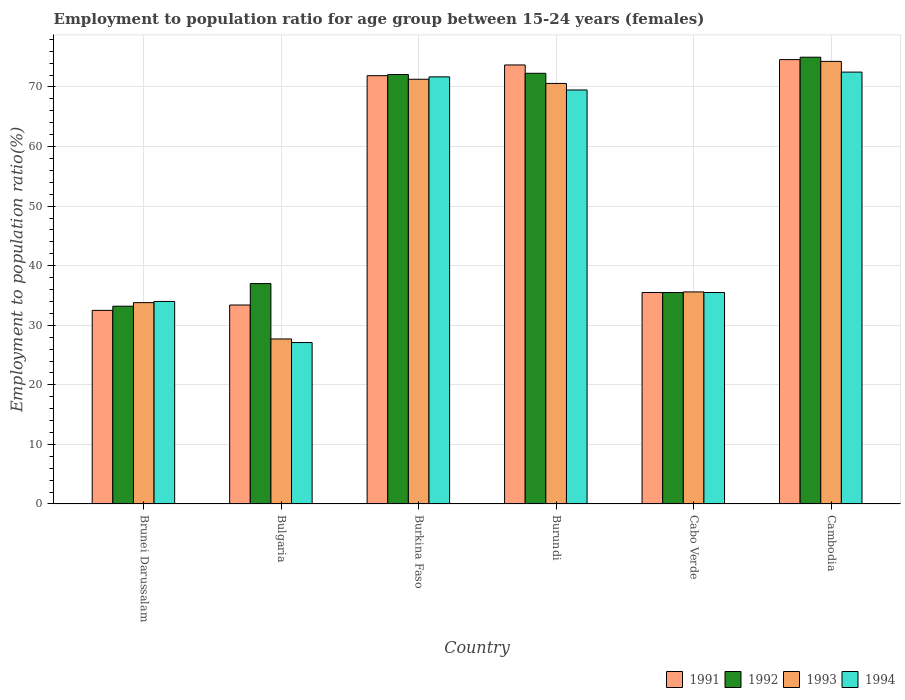How many groups of bars are there?
Your answer should be compact. 6. Are the number of bars per tick equal to the number of legend labels?
Your answer should be very brief. Yes. How many bars are there on the 3rd tick from the right?
Offer a terse response. 4. What is the label of the 6th group of bars from the left?
Make the answer very short. Cambodia. What is the employment to population ratio in 1992 in Burundi?
Offer a terse response. 72.3. Across all countries, what is the maximum employment to population ratio in 1991?
Offer a terse response. 74.6. Across all countries, what is the minimum employment to population ratio in 1993?
Give a very brief answer. 27.7. In which country was the employment to population ratio in 1992 maximum?
Give a very brief answer. Cambodia. What is the total employment to population ratio in 1992 in the graph?
Provide a short and direct response. 325.1. What is the difference between the employment to population ratio in 1992 in Brunei Darussalam and that in Cambodia?
Provide a succinct answer. -41.8. What is the difference between the employment to population ratio in 1991 in Burundi and the employment to population ratio in 1993 in Bulgaria?
Your answer should be compact. 46. What is the average employment to population ratio in 1993 per country?
Provide a short and direct response. 52.22. What is the difference between the employment to population ratio of/in 1992 and employment to population ratio of/in 1991 in Bulgaria?
Offer a terse response. 3.6. What is the ratio of the employment to population ratio in 1991 in Burkina Faso to that in Cambodia?
Offer a terse response. 0.96. Is the employment to population ratio in 1991 in Brunei Darussalam less than that in Burundi?
Provide a succinct answer. Yes. Is the difference between the employment to population ratio in 1992 in Brunei Darussalam and Cambodia greater than the difference between the employment to population ratio in 1991 in Brunei Darussalam and Cambodia?
Your response must be concise. Yes. What is the difference between the highest and the second highest employment to population ratio in 1994?
Your response must be concise. 3. What is the difference between the highest and the lowest employment to population ratio in 1993?
Provide a short and direct response. 46.6. How many countries are there in the graph?
Your response must be concise. 6. Does the graph contain any zero values?
Give a very brief answer. No. Where does the legend appear in the graph?
Your response must be concise. Bottom right. How are the legend labels stacked?
Ensure brevity in your answer.  Horizontal. What is the title of the graph?
Provide a succinct answer. Employment to population ratio for age group between 15-24 years (females). Does "1991" appear as one of the legend labels in the graph?
Provide a succinct answer. Yes. What is the label or title of the X-axis?
Offer a very short reply. Country. What is the Employment to population ratio(%) in 1991 in Brunei Darussalam?
Provide a succinct answer. 32.5. What is the Employment to population ratio(%) of 1992 in Brunei Darussalam?
Offer a very short reply. 33.2. What is the Employment to population ratio(%) in 1993 in Brunei Darussalam?
Give a very brief answer. 33.8. What is the Employment to population ratio(%) of 1994 in Brunei Darussalam?
Your response must be concise. 34. What is the Employment to population ratio(%) in 1991 in Bulgaria?
Give a very brief answer. 33.4. What is the Employment to population ratio(%) of 1992 in Bulgaria?
Provide a succinct answer. 37. What is the Employment to population ratio(%) in 1993 in Bulgaria?
Offer a terse response. 27.7. What is the Employment to population ratio(%) of 1994 in Bulgaria?
Provide a succinct answer. 27.1. What is the Employment to population ratio(%) in 1991 in Burkina Faso?
Provide a short and direct response. 71.9. What is the Employment to population ratio(%) of 1992 in Burkina Faso?
Your response must be concise. 72.1. What is the Employment to population ratio(%) in 1993 in Burkina Faso?
Your answer should be very brief. 71.3. What is the Employment to population ratio(%) of 1994 in Burkina Faso?
Provide a succinct answer. 71.7. What is the Employment to population ratio(%) of 1991 in Burundi?
Your response must be concise. 73.7. What is the Employment to population ratio(%) in 1992 in Burundi?
Offer a very short reply. 72.3. What is the Employment to population ratio(%) in 1993 in Burundi?
Offer a very short reply. 70.6. What is the Employment to population ratio(%) in 1994 in Burundi?
Provide a short and direct response. 69.5. What is the Employment to population ratio(%) of 1991 in Cabo Verde?
Provide a succinct answer. 35.5. What is the Employment to population ratio(%) in 1992 in Cabo Verde?
Your answer should be very brief. 35.5. What is the Employment to population ratio(%) of 1993 in Cabo Verde?
Provide a succinct answer. 35.6. What is the Employment to population ratio(%) of 1994 in Cabo Verde?
Your answer should be very brief. 35.5. What is the Employment to population ratio(%) in 1991 in Cambodia?
Ensure brevity in your answer.  74.6. What is the Employment to population ratio(%) of 1993 in Cambodia?
Keep it short and to the point. 74.3. What is the Employment to population ratio(%) of 1994 in Cambodia?
Provide a short and direct response. 72.5. Across all countries, what is the maximum Employment to population ratio(%) in 1991?
Keep it short and to the point. 74.6. Across all countries, what is the maximum Employment to population ratio(%) of 1993?
Your answer should be compact. 74.3. Across all countries, what is the maximum Employment to population ratio(%) of 1994?
Ensure brevity in your answer.  72.5. Across all countries, what is the minimum Employment to population ratio(%) in 1991?
Ensure brevity in your answer.  32.5. Across all countries, what is the minimum Employment to population ratio(%) of 1992?
Provide a short and direct response. 33.2. Across all countries, what is the minimum Employment to population ratio(%) in 1993?
Provide a succinct answer. 27.7. Across all countries, what is the minimum Employment to population ratio(%) of 1994?
Offer a terse response. 27.1. What is the total Employment to population ratio(%) of 1991 in the graph?
Your answer should be very brief. 321.6. What is the total Employment to population ratio(%) of 1992 in the graph?
Ensure brevity in your answer.  325.1. What is the total Employment to population ratio(%) of 1993 in the graph?
Ensure brevity in your answer.  313.3. What is the total Employment to population ratio(%) in 1994 in the graph?
Ensure brevity in your answer.  310.3. What is the difference between the Employment to population ratio(%) of 1991 in Brunei Darussalam and that in Bulgaria?
Offer a very short reply. -0.9. What is the difference between the Employment to population ratio(%) of 1992 in Brunei Darussalam and that in Bulgaria?
Provide a succinct answer. -3.8. What is the difference between the Employment to population ratio(%) in 1993 in Brunei Darussalam and that in Bulgaria?
Offer a terse response. 6.1. What is the difference between the Employment to population ratio(%) of 1991 in Brunei Darussalam and that in Burkina Faso?
Provide a short and direct response. -39.4. What is the difference between the Employment to population ratio(%) in 1992 in Brunei Darussalam and that in Burkina Faso?
Your answer should be compact. -38.9. What is the difference between the Employment to population ratio(%) of 1993 in Brunei Darussalam and that in Burkina Faso?
Make the answer very short. -37.5. What is the difference between the Employment to population ratio(%) in 1994 in Brunei Darussalam and that in Burkina Faso?
Provide a short and direct response. -37.7. What is the difference between the Employment to population ratio(%) in 1991 in Brunei Darussalam and that in Burundi?
Give a very brief answer. -41.2. What is the difference between the Employment to population ratio(%) of 1992 in Brunei Darussalam and that in Burundi?
Your answer should be very brief. -39.1. What is the difference between the Employment to population ratio(%) of 1993 in Brunei Darussalam and that in Burundi?
Offer a terse response. -36.8. What is the difference between the Employment to population ratio(%) in 1994 in Brunei Darussalam and that in Burundi?
Your answer should be very brief. -35.5. What is the difference between the Employment to population ratio(%) of 1991 in Brunei Darussalam and that in Cabo Verde?
Offer a terse response. -3. What is the difference between the Employment to population ratio(%) in 1992 in Brunei Darussalam and that in Cabo Verde?
Make the answer very short. -2.3. What is the difference between the Employment to population ratio(%) in 1993 in Brunei Darussalam and that in Cabo Verde?
Provide a short and direct response. -1.8. What is the difference between the Employment to population ratio(%) in 1991 in Brunei Darussalam and that in Cambodia?
Provide a short and direct response. -42.1. What is the difference between the Employment to population ratio(%) in 1992 in Brunei Darussalam and that in Cambodia?
Keep it short and to the point. -41.8. What is the difference between the Employment to population ratio(%) in 1993 in Brunei Darussalam and that in Cambodia?
Offer a very short reply. -40.5. What is the difference between the Employment to population ratio(%) of 1994 in Brunei Darussalam and that in Cambodia?
Offer a terse response. -38.5. What is the difference between the Employment to population ratio(%) of 1991 in Bulgaria and that in Burkina Faso?
Offer a very short reply. -38.5. What is the difference between the Employment to population ratio(%) in 1992 in Bulgaria and that in Burkina Faso?
Provide a short and direct response. -35.1. What is the difference between the Employment to population ratio(%) in 1993 in Bulgaria and that in Burkina Faso?
Provide a short and direct response. -43.6. What is the difference between the Employment to population ratio(%) in 1994 in Bulgaria and that in Burkina Faso?
Your response must be concise. -44.6. What is the difference between the Employment to population ratio(%) of 1991 in Bulgaria and that in Burundi?
Your answer should be very brief. -40.3. What is the difference between the Employment to population ratio(%) in 1992 in Bulgaria and that in Burundi?
Your answer should be very brief. -35.3. What is the difference between the Employment to population ratio(%) of 1993 in Bulgaria and that in Burundi?
Provide a short and direct response. -42.9. What is the difference between the Employment to population ratio(%) of 1994 in Bulgaria and that in Burundi?
Your answer should be very brief. -42.4. What is the difference between the Employment to population ratio(%) in 1991 in Bulgaria and that in Cabo Verde?
Your answer should be compact. -2.1. What is the difference between the Employment to population ratio(%) of 1993 in Bulgaria and that in Cabo Verde?
Your answer should be very brief. -7.9. What is the difference between the Employment to population ratio(%) of 1994 in Bulgaria and that in Cabo Verde?
Your response must be concise. -8.4. What is the difference between the Employment to population ratio(%) in 1991 in Bulgaria and that in Cambodia?
Your answer should be very brief. -41.2. What is the difference between the Employment to population ratio(%) of 1992 in Bulgaria and that in Cambodia?
Your response must be concise. -38. What is the difference between the Employment to population ratio(%) of 1993 in Bulgaria and that in Cambodia?
Offer a very short reply. -46.6. What is the difference between the Employment to population ratio(%) of 1994 in Bulgaria and that in Cambodia?
Your answer should be compact. -45.4. What is the difference between the Employment to population ratio(%) of 1991 in Burkina Faso and that in Cabo Verde?
Keep it short and to the point. 36.4. What is the difference between the Employment to population ratio(%) in 1992 in Burkina Faso and that in Cabo Verde?
Ensure brevity in your answer.  36.6. What is the difference between the Employment to population ratio(%) in 1993 in Burkina Faso and that in Cabo Verde?
Make the answer very short. 35.7. What is the difference between the Employment to population ratio(%) in 1994 in Burkina Faso and that in Cabo Verde?
Give a very brief answer. 36.2. What is the difference between the Employment to population ratio(%) in 1994 in Burkina Faso and that in Cambodia?
Give a very brief answer. -0.8. What is the difference between the Employment to population ratio(%) in 1991 in Burundi and that in Cabo Verde?
Offer a very short reply. 38.2. What is the difference between the Employment to population ratio(%) in 1992 in Burundi and that in Cabo Verde?
Your response must be concise. 36.8. What is the difference between the Employment to population ratio(%) in 1994 in Burundi and that in Cabo Verde?
Provide a succinct answer. 34. What is the difference between the Employment to population ratio(%) in 1991 in Burundi and that in Cambodia?
Your answer should be compact. -0.9. What is the difference between the Employment to population ratio(%) in 1992 in Burundi and that in Cambodia?
Offer a very short reply. -2.7. What is the difference between the Employment to population ratio(%) in 1993 in Burundi and that in Cambodia?
Offer a very short reply. -3.7. What is the difference between the Employment to population ratio(%) of 1994 in Burundi and that in Cambodia?
Ensure brevity in your answer.  -3. What is the difference between the Employment to population ratio(%) in 1991 in Cabo Verde and that in Cambodia?
Offer a terse response. -39.1. What is the difference between the Employment to population ratio(%) in 1992 in Cabo Verde and that in Cambodia?
Ensure brevity in your answer.  -39.5. What is the difference between the Employment to population ratio(%) in 1993 in Cabo Verde and that in Cambodia?
Provide a succinct answer. -38.7. What is the difference between the Employment to population ratio(%) in 1994 in Cabo Verde and that in Cambodia?
Make the answer very short. -37. What is the difference between the Employment to population ratio(%) of 1991 in Brunei Darussalam and the Employment to population ratio(%) of 1994 in Bulgaria?
Ensure brevity in your answer.  5.4. What is the difference between the Employment to population ratio(%) of 1993 in Brunei Darussalam and the Employment to population ratio(%) of 1994 in Bulgaria?
Give a very brief answer. 6.7. What is the difference between the Employment to population ratio(%) of 1991 in Brunei Darussalam and the Employment to population ratio(%) of 1992 in Burkina Faso?
Keep it short and to the point. -39.6. What is the difference between the Employment to population ratio(%) in 1991 in Brunei Darussalam and the Employment to population ratio(%) in 1993 in Burkina Faso?
Offer a very short reply. -38.8. What is the difference between the Employment to population ratio(%) in 1991 in Brunei Darussalam and the Employment to population ratio(%) in 1994 in Burkina Faso?
Your answer should be compact. -39.2. What is the difference between the Employment to population ratio(%) in 1992 in Brunei Darussalam and the Employment to population ratio(%) in 1993 in Burkina Faso?
Give a very brief answer. -38.1. What is the difference between the Employment to population ratio(%) of 1992 in Brunei Darussalam and the Employment to population ratio(%) of 1994 in Burkina Faso?
Keep it short and to the point. -38.5. What is the difference between the Employment to population ratio(%) of 1993 in Brunei Darussalam and the Employment to population ratio(%) of 1994 in Burkina Faso?
Offer a terse response. -37.9. What is the difference between the Employment to population ratio(%) of 1991 in Brunei Darussalam and the Employment to population ratio(%) of 1992 in Burundi?
Your answer should be compact. -39.8. What is the difference between the Employment to population ratio(%) of 1991 in Brunei Darussalam and the Employment to population ratio(%) of 1993 in Burundi?
Make the answer very short. -38.1. What is the difference between the Employment to population ratio(%) of 1991 in Brunei Darussalam and the Employment to population ratio(%) of 1994 in Burundi?
Offer a terse response. -37. What is the difference between the Employment to population ratio(%) in 1992 in Brunei Darussalam and the Employment to population ratio(%) in 1993 in Burundi?
Keep it short and to the point. -37.4. What is the difference between the Employment to population ratio(%) of 1992 in Brunei Darussalam and the Employment to population ratio(%) of 1994 in Burundi?
Give a very brief answer. -36.3. What is the difference between the Employment to population ratio(%) of 1993 in Brunei Darussalam and the Employment to population ratio(%) of 1994 in Burundi?
Give a very brief answer. -35.7. What is the difference between the Employment to population ratio(%) of 1991 in Brunei Darussalam and the Employment to population ratio(%) of 1992 in Cabo Verde?
Give a very brief answer. -3. What is the difference between the Employment to population ratio(%) in 1992 in Brunei Darussalam and the Employment to population ratio(%) in 1993 in Cabo Verde?
Your answer should be very brief. -2.4. What is the difference between the Employment to population ratio(%) of 1992 in Brunei Darussalam and the Employment to population ratio(%) of 1994 in Cabo Verde?
Your answer should be compact. -2.3. What is the difference between the Employment to population ratio(%) of 1991 in Brunei Darussalam and the Employment to population ratio(%) of 1992 in Cambodia?
Your response must be concise. -42.5. What is the difference between the Employment to population ratio(%) in 1991 in Brunei Darussalam and the Employment to population ratio(%) in 1993 in Cambodia?
Keep it short and to the point. -41.8. What is the difference between the Employment to population ratio(%) of 1992 in Brunei Darussalam and the Employment to population ratio(%) of 1993 in Cambodia?
Your response must be concise. -41.1. What is the difference between the Employment to population ratio(%) of 1992 in Brunei Darussalam and the Employment to population ratio(%) of 1994 in Cambodia?
Your response must be concise. -39.3. What is the difference between the Employment to population ratio(%) in 1993 in Brunei Darussalam and the Employment to population ratio(%) in 1994 in Cambodia?
Your answer should be very brief. -38.7. What is the difference between the Employment to population ratio(%) of 1991 in Bulgaria and the Employment to population ratio(%) of 1992 in Burkina Faso?
Keep it short and to the point. -38.7. What is the difference between the Employment to population ratio(%) in 1991 in Bulgaria and the Employment to population ratio(%) in 1993 in Burkina Faso?
Make the answer very short. -37.9. What is the difference between the Employment to population ratio(%) in 1991 in Bulgaria and the Employment to population ratio(%) in 1994 in Burkina Faso?
Your response must be concise. -38.3. What is the difference between the Employment to population ratio(%) in 1992 in Bulgaria and the Employment to population ratio(%) in 1993 in Burkina Faso?
Ensure brevity in your answer.  -34.3. What is the difference between the Employment to population ratio(%) in 1992 in Bulgaria and the Employment to population ratio(%) in 1994 in Burkina Faso?
Ensure brevity in your answer.  -34.7. What is the difference between the Employment to population ratio(%) of 1993 in Bulgaria and the Employment to population ratio(%) of 1994 in Burkina Faso?
Your answer should be compact. -44. What is the difference between the Employment to population ratio(%) of 1991 in Bulgaria and the Employment to population ratio(%) of 1992 in Burundi?
Provide a succinct answer. -38.9. What is the difference between the Employment to population ratio(%) of 1991 in Bulgaria and the Employment to population ratio(%) of 1993 in Burundi?
Provide a succinct answer. -37.2. What is the difference between the Employment to population ratio(%) in 1991 in Bulgaria and the Employment to population ratio(%) in 1994 in Burundi?
Your answer should be very brief. -36.1. What is the difference between the Employment to population ratio(%) of 1992 in Bulgaria and the Employment to population ratio(%) of 1993 in Burundi?
Offer a very short reply. -33.6. What is the difference between the Employment to population ratio(%) in 1992 in Bulgaria and the Employment to population ratio(%) in 1994 in Burundi?
Give a very brief answer. -32.5. What is the difference between the Employment to population ratio(%) in 1993 in Bulgaria and the Employment to population ratio(%) in 1994 in Burundi?
Make the answer very short. -41.8. What is the difference between the Employment to population ratio(%) in 1991 in Bulgaria and the Employment to population ratio(%) in 1994 in Cabo Verde?
Ensure brevity in your answer.  -2.1. What is the difference between the Employment to population ratio(%) of 1992 in Bulgaria and the Employment to population ratio(%) of 1994 in Cabo Verde?
Provide a succinct answer. 1.5. What is the difference between the Employment to population ratio(%) in 1991 in Bulgaria and the Employment to population ratio(%) in 1992 in Cambodia?
Provide a succinct answer. -41.6. What is the difference between the Employment to population ratio(%) of 1991 in Bulgaria and the Employment to population ratio(%) of 1993 in Cambodia?
Ensure brevity in your answer.  -40.9. What is the difference between the Employment to population ratio(%) of 1991 in Bulgaria and the Employment to population ratio(%) of 1994 in Cambodia?
Ensure brevity in your answer.  -39.1. What is the difference between the Employment to population ratio(%) of 1992 in Bulgaria and the Employment to population ratio(%) of 1993 in Cambodia?
Provide a short and direct response. -37.3. What is the difference between the Employment to population ratio(%) in 1992 in Bulgaria and the Employment to population ratio(%) in 1994 in Cambodia?
Make the answer very short. -35.5. What is the difference between the Employment to population ratio(%) in 1993 in Bulgaria and the Employment to population ratio(%) in 1994 in Cambodia?
Provide a succinct answer. -44.8. What is the difference between the Employment to population ratio(%) in 1991 in Burkina Faso and the Employment to population ratio(%) in 1993 in Burundi?
Provide a succinct answer. 1.3. What is the difference between the Employment to population ratio(%) of 1992 in Burkina Faso and the Employment to population ratio(%) of 1993 in Burundi?
Offer a very short reply. 1.5. What is the difference between the Employment to population ratio(%) of 1992 in Burkina Faso and the Employment to population ratio(%) of 1994 in Burundi?
Offer a very short reply. 2.6. What is the difference between the Employment to population ratio(%) in 1993 in Burkina Faso and the Employment to population ratio(%) in 1994 in Burundi?
Give a very brief answer. 1.8. What is the difference between the Employment to population ratio(%) in 1991 in Burkina Faso and the Employment to population ratio(%) in 1992 in Cabo Verde?
Your answer should be compact. 36.4. What is the difference between the Employment to population ratio(%) in 1991 in Burkina Faso and the Employment to population ratio(%) in 1993 in Cabo Verde?
Offer a very short reply. 36.3. What is the difference between the Employment to population ratio(%) of 1991 in Burkina Faso and the Employment to population ratio(%) of 1994 in Cabo Verde?
Your answer should be very brief. 36.4. What is the difference between the Employment to population ratio(%) of 1992 in Burkina Faso and the Employment to population ratio(%) of 1993 in Cabo Verde?
Provide a succinct answer. 36.5. What is the difference between the Employment to population ratio(%) of 1992 in Burkina Faso and the Employment to population ratio(%) of 1994 in Cabo Verde?
Your response must be concise. 36.6. What is the difference between the Employment to population ratio(%) in 1993 in Burkina Faso and the Employment to population ratio(%) in 1994 in Cabo Verde?
Keep it short and to the point. 35.8. What is the difference between the Employment to population ratio(%) of 1991 in Burkina Faso and the Employment to population ratio(%) of 1994 in Cambodia?
Your answer should be compact. -0.6. What is the difference between the Employment to population ratio(%) of 1992 in Burkina Faso and the Employment to population ratio(%) of 1993 in Cambodia?
Your answer should be compact. -2.2. What is the difference between the Employment to population ratio(%) of 1992 in Burkina Faso and the Employment to population ratio(%) of 1994 in Cambodia?
Your response must be concise. -0.4. What is the difference between the Employment to population ratio(%) in 1991 in Burundi and the Employment to population ratio(%) in 1992 in Cabo Verde?
Provide a succinct answer. 38.2. What is the difference between the Employment to population ratio(%) of 1991 in Burundi and the Employment to population ratio(%) of 1993 in Cabo Verde?
Your answer should be compact. 38.1. What is the difference between the Employment to population ratio(%) in 1991 in Burundi and the Employment to population ratio(%) in 1994 in Cabo Verde?
Make the answer very short. 38.2. What is the difference between the Employment to population ratio(%) of 1992 in Burundi and the Employment to population ratio(%) of 1993 in Cabo Verde?
Ensure brevity in your answer.  36.7. What is the difference between the Employment to population ratio(%) in 1992 in Burundi and the Employment to population ratio(%) in 1994 in Cabo Verde?
Give a very brief answer. 36.8. What is the difference between the Employment to population ratio(%) of 1993 in Burundi and the Employment to population ratio(%) of 1994 in Cabo Verde?
Your answer should be compact. 35.1. What is the difference between the Employment to population ratio(%) in 1991 in Burundi and the Employment to population ratio(%) in 1992 in Cambodia?
Give a very brief answer. -1.3. What is the difference between the Employment to population ratio(%) in 1991 in Burundi and the Employment to population ratio(%) in 1993 in Cambodia?
Your response must be concise. -0.6. What is the difference between the Employment to population ratio(%) of 1991 in Burundi and the Employment to population ratio(%) of 1994 in Cambodia?
Your answer should be compact. 1.2. What is the difference between the Employment to population ratio(%) in 1992 in Burundi and the Employment to population ratio(%) in 1993 in Cambodia?
Your response must be concise. -2. What is the difference between the Employment to population ratio(%) in 1991 in Cabo Verde and the Employment to population ratio(%) in 1992 in Cambodia?
Provide a succinct answer. -39.5. What is the difference between the Employment to population ratio(%) of 1991 in Cabo Verde and the Employment to population ratio(%) of 1993 in Cambodia?
Your answer should be compact. -38.8. What is the difference between the Employment to population ratio(%) in 1991 in Cabo Verde and the Employment to population ratio(%) in 1994 in Cambodia?
Your response must be concise. -37. What is the difference between the Employment to population ratio(%) in 1992 in Cabo Verde and the Employment to population ratio(%) in 1993 in Cambodia?
Your answer should be very brief. -38.8. What is the difference between the Employment to population ratio(%) in 1992 in Cabo Verde and the Employment to population ratio(%) in 1994 in Cambodia?
Offer a terse response. -37. What is the difference between the Employment to population ratio(%) in 1993 in Cabo Verde and the Employment to population ratio(%) in 1994 in Cambodia?
Provide a succinct answer. -36.9. What is the average Employment to population ratio(%) of 1991 per country?
Your response must be concise. 53.6. What is the average Employment to population ratio(%) in 1992 per country?
Your answer should be compact. 54.18. What is the average Employment to population ratio(%) in 1993 per country?
Your answer should be very brief. 52.22. What is the average Employment to population ratio(%) of 1994 per country?
Make the answer very short. 51.72. What is the difference between the Employment to population ratio(%) in 1991 and Employment to population ratio(%) in 1992 in Brunei Darussalam?
Ensure brevity in your answer.  -0.7. What is the difference between the Employment to population ratio(%) of 1992 and Employment to population ratio(%) of 1993 in Brunei Darussalam?
Make the answer very short. -0.6. What is the difference between the Employment to population ratio(%) of 1993 and Employment to population ratio(%) of 1994 in Brunei Darussalam?
Keep it short and to the point. -0.2. What is the difference between the Employment to population ratio(%) of 1991 and Employment to population ratio(%) of 1992 in Bulgaria?
Offer a very short reply. -3.6. What is the difference between the Employment to population ratio(%) of 1991 and Employment to population ratio(%) of 1993 in Bulgaria?
Your answer should be compact. 5.7. What is the difference between the Employment to population ratio(%) of 1991 and Employment to population ratio(%) of 1994 in Bulgaria?
Make the answer very short. 6.3. What is the difference between the Employment to population ratio(%) of 1992 and Employment to population ratio(%) of 1993 in Bulgaria?
Your answer should be compact. 9.3. What is the difference between the Employment to population ratio(%) in 1992 and Employment to population ratio(%) in 1994 in Bulgaria?
Provide a succinct answer. 9.9. What is the difference between the Employment to population ratio(%) of 1993 and Employment to population ratio(%) of 1994 in Bulgaria?
Your answer should be compact. 0.6. What is the difference between the Employment to population ratio(%) in 1991 and Employment to population ratio(%) in 1993 in Burkina Faso?
Keep it short and to the point. 0.6. What is the difference between the Employment to population ratio(%) of 1992 and Employment to population ratio(%) of 1993 in Burkina Faso?
Your response must be concise. 0.8. What is the difference between the Employment to population ratio(%) of 1992 and Employment to population ratio(%) of 1994 in Burkina Faso?
Your answer should be compact. 0.4. What is the difference between the Employment to population ratio(%) in 1993 and Employment to population ratio(%) in 1994 in Burkina Faso?
Your response must be concise. -0.4. What is the difference between the Employment to population ratio(%) of 1991 and Employment to population ratio(%) of 1992 in Burundi?
Offer a terse response. 1.4. What is the difference between the Employment to population ratio(%) of 1991 and Employment to population ratio(%) of 1993 in Burundi?
Your response must be concise. 3.1. What is the difference between the Employment to population ratio(%) of 1992 and Employment to population ratio(%) of 1993 in Burundi?
Your answer should be very brief. 1.7. What is the difference between the Employment to population ratio(%) in 1993 and Employment to population ratio(%) in 1994 in Burundi?
Your response must be concise. 1.1. What is the difference between the Employment to population ratio(%) of 1991 and Employment to population ratio(%) of 1992 in Cabo Verde?
Keep it short and to the point. 0. What is the difference between the Employment to population ratio(%) in 1991 and Employment to population ratio(%) in 1993 in Cabo Verde?
Provide a short and direct response. -0.1. What is the difference between the Employment to population ratio(%) of 1991 and Employment to population ratio(%) of 1992 in Cambodia?
Give a very brief answer. -0.4. What is the difference between the Employment to population ratio(%) of 1991 and Employment to population ratio(%) of 1993 in Cambodia?
Your answer should be very brief. 0.3. What is the difference between the Employment to population ratio(%) of 1991 and Employment to population ratio(%) of 1994 in Cambodia?
Offer a very short reply. 2.1. What is the difference between the Employment to population ratio(%) of 1993 and Employment to population ratio(%) of 1994 in Cambodia?
Offer a very short reply. 1.8. What is the ratio of the Employment to population ratio(%) in 1991 in Brunei Darussalam to that in Bulgaria?
Keep it short and to the point. 0.97. What is the ratio of the Employment to population ratio(%) in 1992 in Brunei Darussalam to that in Bulgaria?
Offer a very short reply. 0.9. What is the ratio of the Employment to population ratio(%) of 1993 in Brunei Darussalam to that in Bulgaria?
Your response must be concise. 1.22. What is the ratio of the Employment to population ratio(%) of 1994 in Brunei Darussalam to that in Bulgaria?
Provide a short and direct response. 1.25. What is the ratio of the Employment to population ratio(%) in 1991 in Brunei Darussalam to that in Burkina Faso?
Your answer should be compact. 0.45. What is the ratio of the Employment to population ratio(%) in 1992 in Brunei Darussalam to that in Burkina Faso?
Keep it short and to the point. 0.46. What is the ratio of the Employment to population ratio(%) of 1993 in Brunei Darussalam to that in Burkina Faso?
Your response must be concise. 0.47. What is the ratio of the Employment to population ratio(%) of 1994 in Brunei Darussalam to that in Burkina Faso?
Give a very brief answer. 0.47. What is the ratio of the Employment to population ratio(%) in 1991 in Brunei Darussalam to that in Burundi?
Provide a short and direct response. 0.44. What is the ratio of the Employment to population ratio(%) of 1992 in Brunei Darussalam to that in Burundi?
Provide a succinct answer. 0.46. What is the ratio of the Employment to population ratio(%) of 1993 in Brunei Darussalam to that in Burundi?
Ensure brevity in your answer.  0.48. What is the ratio of the Employment to population ratio(%) in 1994 in Brunei Darussalam to that in Burundi?
Make the answer very short. 0.49. What is the ratio of the Employment to population ratio(%) of 1991 in Brunei Darussalam to that in Cabo Verde?
Keep it short and to the point. 0.92. What is the ratio of the Employment to population ratio(%) of 1992 in Brunei Darussalam to that in Cabo Verde?
Provide a succinct answer. 0.94. What is the ratio of the Employment to population ratio(%) in 1993 in Brunei Darussalam to that in Cabo Verde?
Keep it short and to the point. 0.95. What is the ratio of the Employment to population ratio(%) in 1994 in Brunei Darussalam to that in Cabo Verde?
Give a very brief answer. 0.96. What is the ratio of the Employment to population ratio(%) in 1991 in Brunei Darussalam to that in Cambodia?
Offer a terse response. 0.44. What is the ratio of the Employment to population ratio(%) in 1992 in Brunei Darussalam to that in Cambodia?
Your answer should be compact. 0.44. What is the ratio of the Employment to population ratio(%) in 1993 in Brunei Darussalam to that in Cambodia?
Provide a short and direct response. 0.45. What is the ratio of the Employment to population ratio(%) in 1994 in Brunei Darussalam to that in Cambodia?
Offer a terse response. 0.47. What is the ratio of the Employment to population ratio(%) in 1991 in Bulgaria to that in Burkina Faso?
Make the answer very short. 0.46. What is the ratio of the Employment to population ratio(%) of 1992 in Bulgaria to that in Burkina Faso?
Your answer should be very brief. 0.51. What is the ratio of the Employment to population ratio(%) of 1993 in Bulgaria to that in Burkina Faso?
Give a very brief answer. 0.39. What is the ratio of the Employment to population ratio(%) of 1994 in Bulgaria to that in Burkina Faso?
Offer a terse response. 0.38. What is the ratio of the Employment to population ratio(%) of 1991 in Bulgaria to that in Burundi?
Give a very brief answer. 0.45. What is the ratio of the Employment to population ratio(%) in 1992 in Bulgaria to that in Burundi?
Provide a succinct answer. 0.51. What is the ratio of the Employment to population ratio(%) of 1993 in Bulgaria to that in Burundi?
Your response must be concise. 0.39. What is the ratio of the Employment to population ratio(%) of 1994 in Bulgaria to that in Burundi?
Make the answer very short. 0.39. What is the ratio of the Employment to population ratio(%) of 1991 in Bulgaria to that in Cabo Verde?
Give a very brief answer. 0.94. What is the ratio of the Employment to population ratio(%) in 1992 in Bulgaria to that in Cabo Verde?
Make the answer very short. 1.04. What is the ratio of the Employment to population ratio(%) of 1993 in Bulgaria to that in Cabo Verde?
Make the answer very short. 0.78. What is the ratio of the Employment to population ratio(%) of 1994 in Bulgaria to that in Cabo Verde?
Ensure brevity in your answer.  0.76. What is the ratio of the Employment to population ratio(%) of 1991 in Bulgaria to that in Cambodia?
Keep it short and to the point. 0.45. What is the ratio of the Employment to population ratio(%) in 1992 in Bulgaria to that in Cambodia?
Make the answer very short. 0.49. What is the ratio of the Employment to population ratio(%) of 1993 in Bulgaria to that in Cambodia?
Ensure brevity in your answer.  0.37. What is the ratio of the Employment to population ratio(%) in 1994 in Bulgaria to that in Cambodia?
Make the answer very short. 0.37. What is the ratio of the Employment to population ratio(%) of 1991 in Burkina Faso to that in Burundi?
Your answer should be compact. 0.98. What is the ratio of the Employment to population ratio(%) in 1993 in Burkina Faso to that in Burundi?
Ensure brevity in your answer.  1.01. What is the ratio of the Employment to population ratio(%) of 1994 in Burkina Faso to that in Burundi?
Your answer should be very brief. 1.03. What is the ratio of the Employment to population ratio(%) of 1991 in Burkina Faso to that in Cabo Verde?
Your answer should be compact. 2.03. What is the ratio of the Employment to population ratio(%) of 1992 in Burkina Faso to that in Cabo Verde?
Make the answer very short. 2.03. What is the ratio of the Employment to population ratio(%) of 1993 in Burkina Faso to that in Cabo Verde?
Offer a very short reply. 2. What is the ratio of the Employment to population ratio(%) in 1994 in Burkina Faso to that in Cabo Verde?
Make the answer very short. 2.02. What is the ratio of the Employment to population ratio(%) of 1991 in Burkina Faso to that in Cambodia?
Offer a very short reply. 0.96. What is the ratio of the Employment to population ratio(%) in 1992 in Burkina Faso to that in Cambodia?
Your response must be concise. 0.96. What is the ratio of the Employment to population ratio(%) of 1993 in Burkina Faso to that in Cambodia?
Make the answer very short. 0.96. What is the ratio of the Employment to population ratio(%) of 1994 in Burkina Faso to that in Cambodia?
Provide a succinct answer. 0.99. What is the ratio of the Employment to population ratio(%) in 1991 in Burundi to that in Cabo Verde?
Provide a short and direct response. 2.08. What is the ratio of the Employment to population ratio(%) of 1992 in Burundi to that in Cabo Verde?
Provide a short and direct response. 2.04. What is the ratio of the Employment to population ratio(%) in 1993 in Burundi to that in Cabo Verde?
Give a very brief answer. 1.98. What is the ratio of the Employment to population ratio(%) of 1994 in Burundi to that in Cabo Verde?
Your answer should be very brief. 1.96. What is the ratio of the Employment to population ratio(%) of 1991 in Burundi to that in Cambodia?
Offer a very short reply. 0.99. What is the ratio of the Employment to population ratio(%) of 1992 in Burundi to that in Cambodia?
Your response must be concise. 0.96. What is the ratio of the Employment to population ratio(%) of 1993 in Burundi to that in Cambodia?
Your response must be concise. 0.95. What is the ratio of the Employment to population ratio(%) of 1994 in Burundi to that in Cambodia?
Your answer should be very brief. 0.96. What is the ratio of the Employment to population ratio(%) in 1991 in Cabo Verde to that in Cambodia?
Your response must be concise. 0.48. What is the ratio of the Employment to population ratio(%) of 1992 in Cabo Verde to that in Cambodia?
Ensure brevity in your answer.  0.47. What is the ratio of the Employment to population ratio(%) of 1993 in Cabo Verde to that in Cambodia?
Give a very brief answer. 0.48. What is the ratio of the Employment to population ratio(%) of 1994 in Cabo Verde to that in Cambodia?
Your response must be concise. 0.49. What is the difference between the highest and the second highest Employment to population ratio(%) of 1991?
Your response must be concise. 0.9. What is the difference between the highest and the second highest Employment to population ratio(%) of 1992?
Your answer should be very brief. 2.7. What is the difference between the highest and the lowest Employment to population ratio(%) of 1991?
Ensure brevity in your answer.  42.1. What is the difference between the highest and the lowest Employment to population ratio(%) of 1992?
Offer a very short reply. 41.8. What is the difference between the highest and the lowest Employment to population ratio(%) of 1993?
Provide a succinct answer. 46.6. What is the difference between the highest and the lowest Employment to population ratio(%) of 1994?
Offer a very short reply. 45.4. 